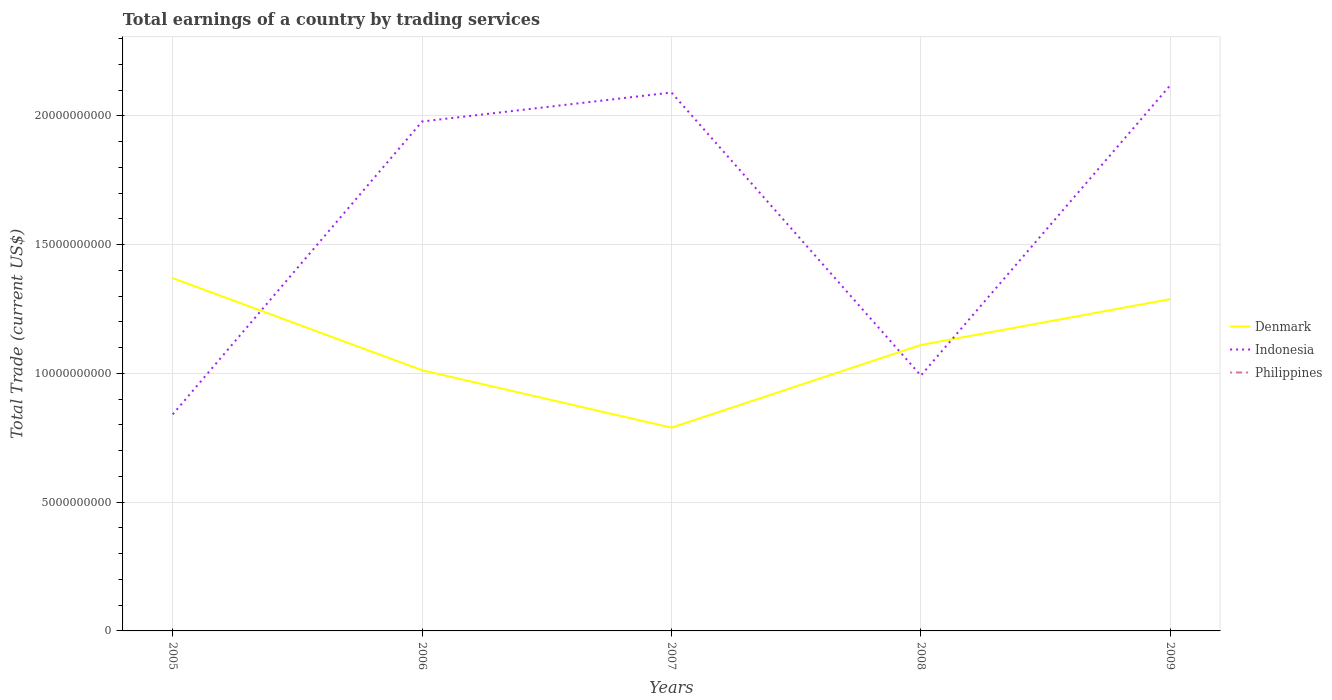How many different coloured lines are there?
Your answer should be compact. 2. Is the number of lines equal to the number of legend labels?
Your answer should be compact. No. What is the total total earnings in Denmark in the graph?
Ensure brevity in your answer.  -4.99e+09. What is the difference between the highest and the second highest total earnings in Indonesia?
Make the answer very short. 1.28e+1. What is the difference between the highest and the lowest total earnings in Indonesia?
Your response must be concise. 3. How many lines are there?
Your answer should be compact. 2. What is the difference between two consecutive major ticks on the Y-axis?
Make the answer very short. 5.00e+09. Are the values on the major ticks of Y-axis written in scientific E-notation?
Make the answer very short. No. Does the graph contain any zero values?
Your answer should be compact. Yes. Does the graph contain grids?
Ensure brevity in your answer.  Yes. How many legend labels are there?
Your response must be concise. 3. What is the title of the graph?
Provide a succinct answer. Total earnings of a country by trading services. What is the label or title of the X-axis?
Make the answer very short. Years. What is the label or title of the Y-axis?
Keep it short and to the point. Total Trade (current US$). What is the Total Trade (current US$) of Denmark in 2005?
Keep it short and to the point. 1.37e+1. What is the Total Trade (current US$) in Indonesia in 2005?
Your answer should be very brief. 8.41e+09. What is the Total Trade (current US$) in Philippines in 2005?
Your answer should be very brief. 0. What is the Total Trade (current US$) in Denmark in 2006?
Your response must be concise. 1.01e+1. What is the Total Trade (current US$) of Indonesia in 2006?
Provide a short and direct response. 1.98e+1. What is the Total Trade (current US$) in Denmark in 2007?
Provide a short and direct response. 7.89e+09. What is the Total Trade (current US$) of Indonesia in 2007?
Provide a succinct answer. 2.09e+1. What is the Total Trade (current US$) of Philippines in 2007?
Provide a succinct answer. 0. What is the Total Trade (current US$) of Denmark in 2008?
Give a very brief answer. 1.11e+1. What is the Total Trade (current US$) of Indonesia in 2008?
Keep it short and to the point. 9.92e+09. What is the Total Trade (current US$) in Philippines in 2008?
Provide a succinct answer. 0. What is the Total Trade (current US$) of Denmark in 2009?
Give a very brief answer. 1.29e+1. What is the Total Trade (current US$) in Indonesia in 2009?
Provide a succinct answer. 2.12e+1. What is the Total Trade (current US$) in Philippines in 2009?
Your response must be concise. 0. Across all years, what is the maximum Total Trade (current US$) in Denmark?
Give a very brief answer. 1.37e+1. Across all years, what is the maximum Total Trade (current US$) in Indonesia?
Make the answer very short. 2.12e+1. Across all years, what is the minimum Total Trade (current US$) in Denmark?
Your answer should be very brief. 7.89e+09. Across all years, what is the minimum Total Trade (current US$) in Indonesia?
Give a very brief answer. 8.41e+09. What is the total Total Trade (current US$) in Denmark in the graph?
Provide a short and direct response. 5.57e+1. What is the total Total Trade (current US$) of Indonesia in the graph?
Offer a very short reply. 8.02e+1. What is the difference between the Total Trade (current US$) in Denmark in 2005 and that in 2006?
Your response must be concise. 3.58e+09. What is the difference between the Total Trade (current US$) in Indonesia in 2005 and that in 2006?
Give a very brief answer. -1.14e+1. What is the difference between the Total Trade (current US$) in Denmark in 2005 and that in 2007?
Provide a short and direct response. 5.81e+09. What is the difference between the Total Trade (current US$) of Indonesia in 2005 and that in 2007?
Your answer should be compact. -1.25e+1. What is the difference between the Total Trade (current US$) in Denmark in 2005 and that in 2008?
Your answer should be very brief. 2.60e+09. What is the difference between the Total Trade (current US$) in Indonesia in 2005 and that in 2008?
Give a very brief answer. -1.51e+09. What is the difference between the Total Trade (current US$) of Denmark in 2005 and that in 2009?
Make the answer very short. 8.15e+08. What is the difference between the Total Trade (current US$) of Indonesia in 2005 and that in 2009?
Make the answer very short. -1.28e+1. What is the difference between the Total Trade (current US$) in Denmark in 2006 and that in 2007?
Ensure brevity in your answer.  2.23e+09. What is the difference between the Total Trade (current US$) of Indonesia in 2006 and that in 2007?
Offer a terse response. -1.13e+09. What is the difference between the Total Trade (current US$) of Denmark in 2006 and that in 2008?
Give a very brief answer. -9.81e+08. What is the difference between the Total Trade (current US$) of Indonesia in 2006 and that in 2008?
Offer a very short reply. 9.87e+09. What is the difference between the Total Trade (current US$) of Denmark in 2006 and that in 2009?
Offer a very short reply. -2.76e+09. What is the difference between the Total Trade (current US$) of Indonesia in 2006 and that in 2009?
Make the answer very short. -1.41e+09. What is the difference between the Total Trade (current US$) in Denmark in 2007 and that in 2008?
Offer a terse response. -3.21e+09. What is the difference between the Total Trade (current US$) in Indonesia in 2007 and that in 2008?
Make the answer very short. 1.10e+1. What is the difference between the Total Trade (current US$) of Denmark in 2007 and that in 2009?
Provide a short and direct response. -4.99e+09. What is the difference between the Total Trade (current US$) of Indonesia in 2007 and that in 2009?
Your answer should be very brief. -2.79e+08. What is the difference between the Total Trade (current US$) of Denmark in 2008 and that in 2009?
Your response must be concise. -1.78e+09. What is the difference between the Total Trade (current US$) in Indonesia in 2008 and that in 2009?
Your response must be concise. -1.13e+1. What is the difference between the Total Trade (current US$) in Denmark in 2005 and the Total Trade (current US$) in Indonesia in 2006?
Your answer should be very brief. -6.08e+09. What is the difference between the Total Trade (current US$) of Denmark in 2005 and the Total Trade (current US$) of Indonesia in 2007?
Ensure brevity in your answer.  -7.21e+09. What is the difference between the Total Trade (current US$) in Denmark in 2005 and the Total Trade (current US$) in Indonesia in 2008?
Offer a terse response. 3.78e+09. What is the difference between the Total Trade (current US$) in Denmark in 2005 and the Total Trade (current US$) in Indonesia in 2009?
Give a very brief answer. -7.49e+09. What is the difference between the Total Trade (current US$) in Denmark in 2006 and the Total Trade (current US$) in Indonesia in 2007?
Offer a terse response. -1.08e+1. What is the difference between the Total Trade (current US$) in Denmark in 2006 and the Total Trade (current US$) in Indonesia in 2008?
Give a very brief answer. 2.07e+08. What is the difference between the Total Trade (current US$) of Denmark in 2006 and the Total Trade (current US$) of Indonesia in 2009?
Ensure brevity in your answer.  -1.11e+1. What is the difference between the Total Trade (current US$) of Denmark in 2007 and the Total Trade (current US$) of Indonesia in 2008?
Provide a succinct answer. -2.02e+09. What is the difference between the Total Trade (current US$) in Denmark in 2007 and the Total Trade (current US$) in Indonesia in 2009?
Keep it short and to the point. -1.33e+1. What is the difference between the Total Trade (current US$) of Denmark in 2008 and the Total Trade (current US$) of Indonesia in 2009?
Provide a short and direct response. -1.01e+1. What is the average Total Trade (current US$) in Denmark per year?
Provide a short and direct response. 1.11e+1. What is the average Total Trade (current US$) in Indonesia per year?
Your answer should be very brief. 1.60e+1. What is the average Total Trade (current US$) of Philippines per year?
Ensure brevity in your answer.  0. In the year 2005, what is the difference between the Total Trade (current US$) of Denmark and Total Trade (current US$) of Indonesia?
Offer a very short reply. 5.29e+09. In the year 2006, what is the difference between the Total Trade (current US$) in Denmark and Total Trade (current US$) in Indonesia?
Make the answer very short. -9.66e+09. In the year 2007, what is the difference between the Total Trade (current US$) of Denmark and Total Trade (current US$) of Indonesia?
Keep it short and to the point. -1.30e+1. In the year 2008, what is the difference between the Total Trade (current US$) of Denmark and Total Trade (current US$) of Indonesia?
Keep it short and to the point. 1.19e+09. In the year 2009, what is the difference between the Total Trade (current US$) in Denmark and Total Trade (current US$) in Indonesia?
Give a very brief answer. -8.30e+09. What is the ratio of the Total Trade (current US$) of Denmark in 2005 to that in 2006?
Provide a short and direct response. 1.35. What is the ratio of the Total Trade (current US$) of Indonesia in 2005 to that in 2006?
Make the answer very short. 0.43. What is the ratio of the Total Trade (current US$) of Denmark in 2005 to that in 2007?
Give a very brief answer. 1.74. What is the ratio of the Total Trade (current US$) in Indonesia in 2005 to that in 2007?
Keep it short and to the point. 0.4. What is the ratio of the Total Trade (current US$) of Denmark in 2005 to that in 2008?
Keep it short and to the point. 1.23. What is the ratio of the Total Trade (current US$) in Indonesia in 2005 to that in 2008?
Provide a succinct answer. 0.85. What is the ratio of the Total Trade (current US$) in Denmark in 2005 to that in 2009?
Make the answer very short. 1.06. What is the ratio of the Total Trade (current US$) of Indonesia in 2005 to that in 2009?
Your answer should be compact. 0.4. What is the ratio of the Total Trade (current US$) in Denmark in 2006 to that in 2007?
Ensure brevity in your answer.  1.28. What is the ratio of the Total Trade (current US$) of Indonesia in 2006 to that in 2007?
Provide a succinct answer. 0.95. What is the ratio of the Total Trade (current US$) of Denmark in 2006 to that in 2008?
Your answer should be compact. 0.91. What is the ratio of the Total Trade (current US$) in Indonesia in 2006 to that in 2008?
Give a very brief answer. 2. What is the ratio of the Total Trade (current US$) of Denmark in 2006 to that in 2009?
Your answer should be compact. 0.79. What is the ratio of the Total Trade (current US$) in Indonesia in 2006 to that in 2009?
Offer a very short reply. 0.93. What is the ratio of the Total Trade (current US$) in Denmark in 2007 to that in 2008?
Your answer should be compact. 0.71. What is the ratio of the Total Trade (current US$) in Indonesia in 2007 to that in 2008?
Give a very brief answer. 2.11. What is the ratio of the Total Trade (current US$) in Denmark in 2007 to that in 2009?
Offer a very short reply. 0.61. What is the ratio of the Total Trade (current US$) of Indonesia in 2007 to that in 2009?
Ensure brevity in your answer.  0.99. What is the ratio of the Total Trade (current US$) of Denmark in 2008 to that in 2009?
Your response must be concise. 0.86. What is the ratio of the Total Trade (current US$) in Indonesia in 2008 to that in 2009?
Give a very brief answer. 0.47. What is the difference between the highest and the second highest Total Trade (current US$) of Denmark?
Provide a succinct answer. 8.15e+08. What is the difference between the highest and the second highest Total Trade (current US$) of Indonesia?
Provide a succinct answer. 2.79e+08. What is the difference between the highest and the lowest Total Trade (current US$) in Denmark?
Give a very brief answer. 5.81e+09. What is the difference between the highest and the lowest Total Trade (current US$) of Indonesia?
Make the answer very short. 1.28e+1. 